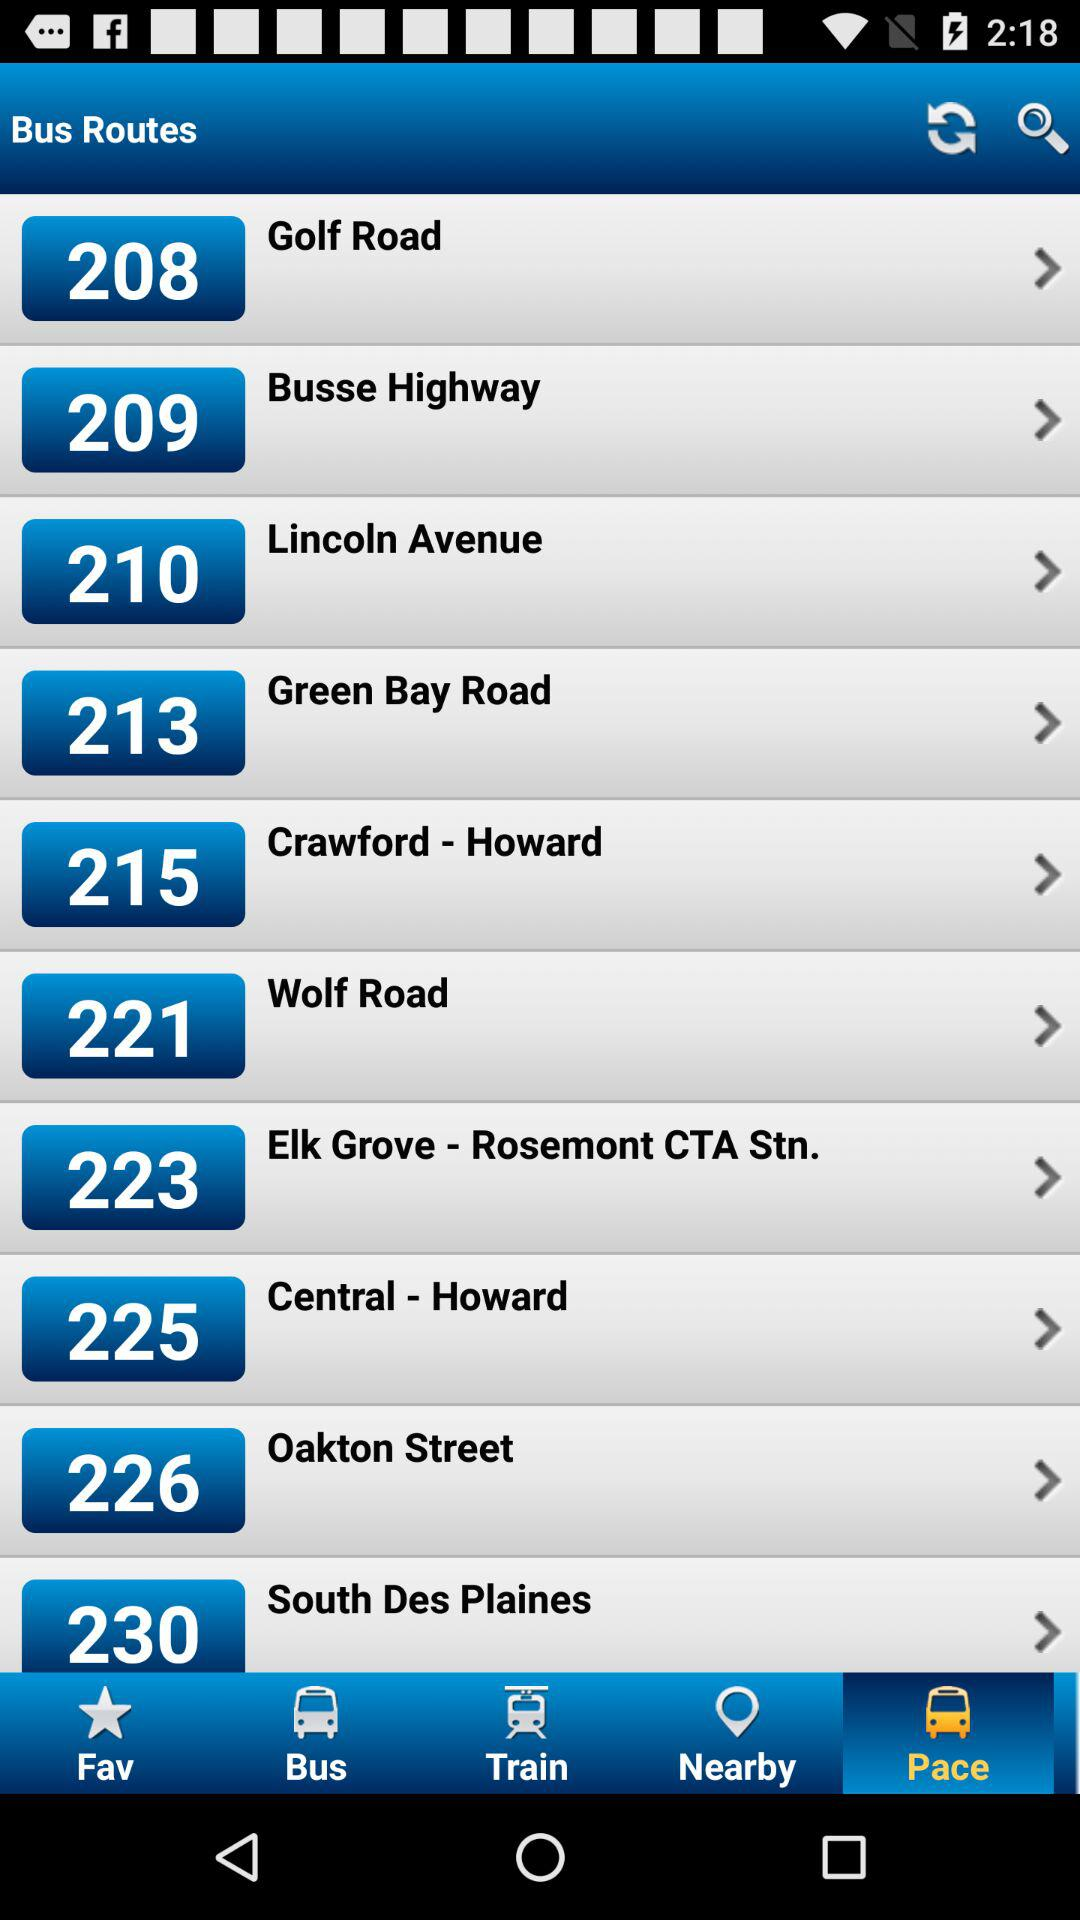How many bus routes are there in total?
Answer the question using a single word or phrase. 10 